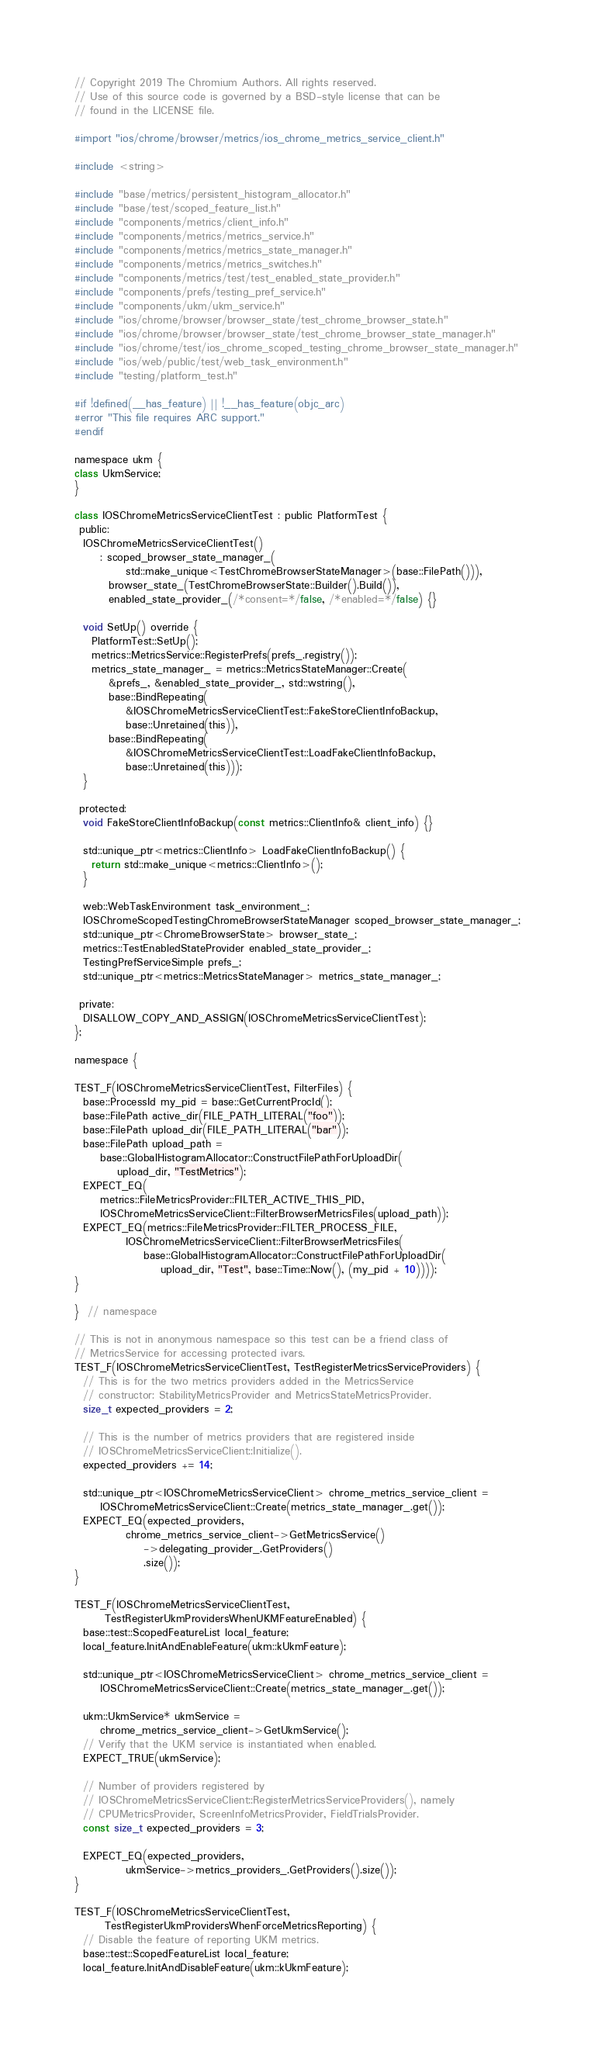<code> <loc_0><loc_0><loc_500><loc_500><_ObjectiveC_>// Copyright 2019 The Chromium Authors. All rights reserved.
// Use of this source code is governed by a BSD-style license that can be
// found in the LICENSE file.

#import "ios/chrome/browser/metrics/ios_chrome_metrics_service_client.h"

#include <string>

#include "base/metrics/persistent_histogram_allocator.h"
#include "base/test/scoped_feature_list.h"
#include "components/metrics/client_info.h"
#include "components/metrics/metrics_service.h"
#include "components/metrics/metrics_state_manager.h"
#include "components/metrics/metrics_switches.h"
#include "components/metrics/test/test_enabled_state_provider.h"
#include "components/prefs/testing_pref_service.h"
#include "components/ukm/ukm_service.h"
#include "ios/chrome/browser/browser_state/test_chrome_browser_state.h"
#include "ios/chrome/browser/browser_state/test_chrome_browser_state_manager.h"
#include "ios/chrome/test/ios_chrome_scoped_testing_chrome_browser_state_manager.h"
#include "ios/web/public/test/web_task_environment.h"
#include "testing/platform_test.h"

#if !defined(__has_feature) || !__has_feature(objc_arc)
#error "This file requires ARC support."
#endif

namespace ukm {
class UkmService;
}

class IOSChromeMetricsServiceClientTest : public PlatformTest {
 public:
  IOSChromeMetricsServiceClientTest()
      : scoped_browser_state_manager_(
            std::make_unique<TestChromeBrowserStateManager>(base::FilePath())),
        browser_state_(TestChromeBrowserState::Builder().Build()),
        enabled_state_provider_(/*consent=*/false, /*enabled=*/false) {}

  void SetUp() override {
    PlatformTest::SetUp();
    metrics::MetricsService::RegisterPrefs(prefs_.registry());
    metrics_state_manager_ = metrics::MetricsStateManager::Create(
        &prefs_, &enabled_state_provider_, std::wstring(),
        base::BindRepeating(
            &IOSChromeMetricsServiceClientTest::FakeStoreClientInfoBackup,
            base::Unretained(this)),
        base::BindRepeating(
            &IOSChromeMetricsServiceClientTest::LoadFakeClientInfoBackup,
            base::Unretained(this)));
  }

 protected:
  void FakeStoreClientInfoBackup(const metrics::ClientInfo& client_info) {}

  std::unique_ptr<metrics::ClientInfo> LoadFakeClientInfoBackup() {
    return std::make_unique<metrics::ClientInfo>();
  }

  web::WebTaskEnvironment task_environment_;
  IOSChromeScopedTestingChromeBrowserStateManager scoped_browser_state_manager_;
  std::unique_ptr<ChromeBrowserState> browser_state_;
  metrics::TestEnabledStateProvider enabled_state_provider_;
  TestingPrefServiceSimple prefs_;
  std::unique_ptr<metrics::MetricsStateManager> metrics_state_manager_;

 private:
  DISALLOW_COPY_AND_ASSIGN(IOSChromeMetricsServiceClientTest);
};

namespace {

TEST_F(IOSChromeMetricsServiceClientTest, FilterFiles) {
  base::ProcessId my_pid = base::GetCurrentProcId();
  base::FilePath active_dir(FILE_PATH_LITERAL("foo"));
  base::FilePath upload_dir(FILE_PATH_LITERAL("bar"));
  base::FilePath upload_path =
      base::GlobalHistogramAllocator::ConstructFilePathForUploadDir(
          upload_dir, "TestMetrics");
  EXPECT_EQ(
      metrics::FileMetricsProvider::FILTER_ACTIVE_THIS_PID,
      IOSChromeMetricsServiceClient::FilterBrowserMetricsFiles(upload_path));
  EXPECT_EQ(metrics::FileMetricsProvider::FILTER_PROCESS_FILE,
            IOSChromeMetricsServiceClient::FilterBrowserMetricsFiles(
                base::GlobalHistogramAllocator::ConstructFilePathForUploadDir(
                    upload_dir, "Test", base::Time::Now(), (my_pid + 10))));
}

}  // namespace

// This is not in anonymous namespace so this test can be a friend class of
// MetricsService for accessing protected ivars.
TEST_F(IOSChromeMetricsServiceClientTest, TestRegisterMetricsServiceProviders) {
  // This is for the two metrics providers added in the MetricsService
  // constructor: StabilityMetricsProvider and MetricsStateMetricsProvider.
  size_t expected_providers = 2;

  // This is the number of metrics providers that are registered inside
  // IOSChromeMetricsServiceClient::Initialize().
  expected_providers += 14;

  std::unique_ptr<IOSChromeMetricsServiceClient> chrome_metrics_service_client =
      IOSChromeMetricsServiceClient::Create(metrics_state_manager_.get());
  EXPECT_EQ(expected_providers,
            chrome_metrics_service_client->GetMetricsService()
                ->delegating_provider_.GetProviders()
                .size());
}

TEST_F(IOSChromeMetricsServiceClientTest,
       TestRegisterUkmProvidersWhenUKMFeatureEnabled) {
  base::test::ScopedFeatureList local_feature;
  local_feature.InitAndEnableFeature(ukm::kUkmFeature);

  std::unique_ptr<IOSChromeMetricsServiceClient> chrome_metrics_service_client =
      IOSChromeMetricsServiceClient::Create(metrics_state_manager_.get());

  ukm::UkmService* ukmService =
      chrome_metrics_service_client->GetUkmService();
  // Verify that the UKM service is instantiated when enabled.
  EXPECT_TRUE(ukmService);

  // Number of providers registered by
  // IOSChromeMetricsServiceClient::RegisterMetricsServiceProviders(), namely
  // CPUMetricsProvider, ScreenInfoMetricsProvider, FieldTrialsProvider.
  const size_t expected_providers = 3;

  EXPECT_EQ(expected_providers,
            ukmService->metrics_providers_.GetProviders().size());
}

TEST_F(IOSChromeMetricsServiceClientTest,
       TestRegisterUkmProvidersWhenForceMetricsReporting) {
  // Disable the feature of reporting UKM metrics.
  base::test::ScopedFeatureList local_feature;
  local_feature.InitAndDisableFeature(ukm::kUkmFeature);
</code> 